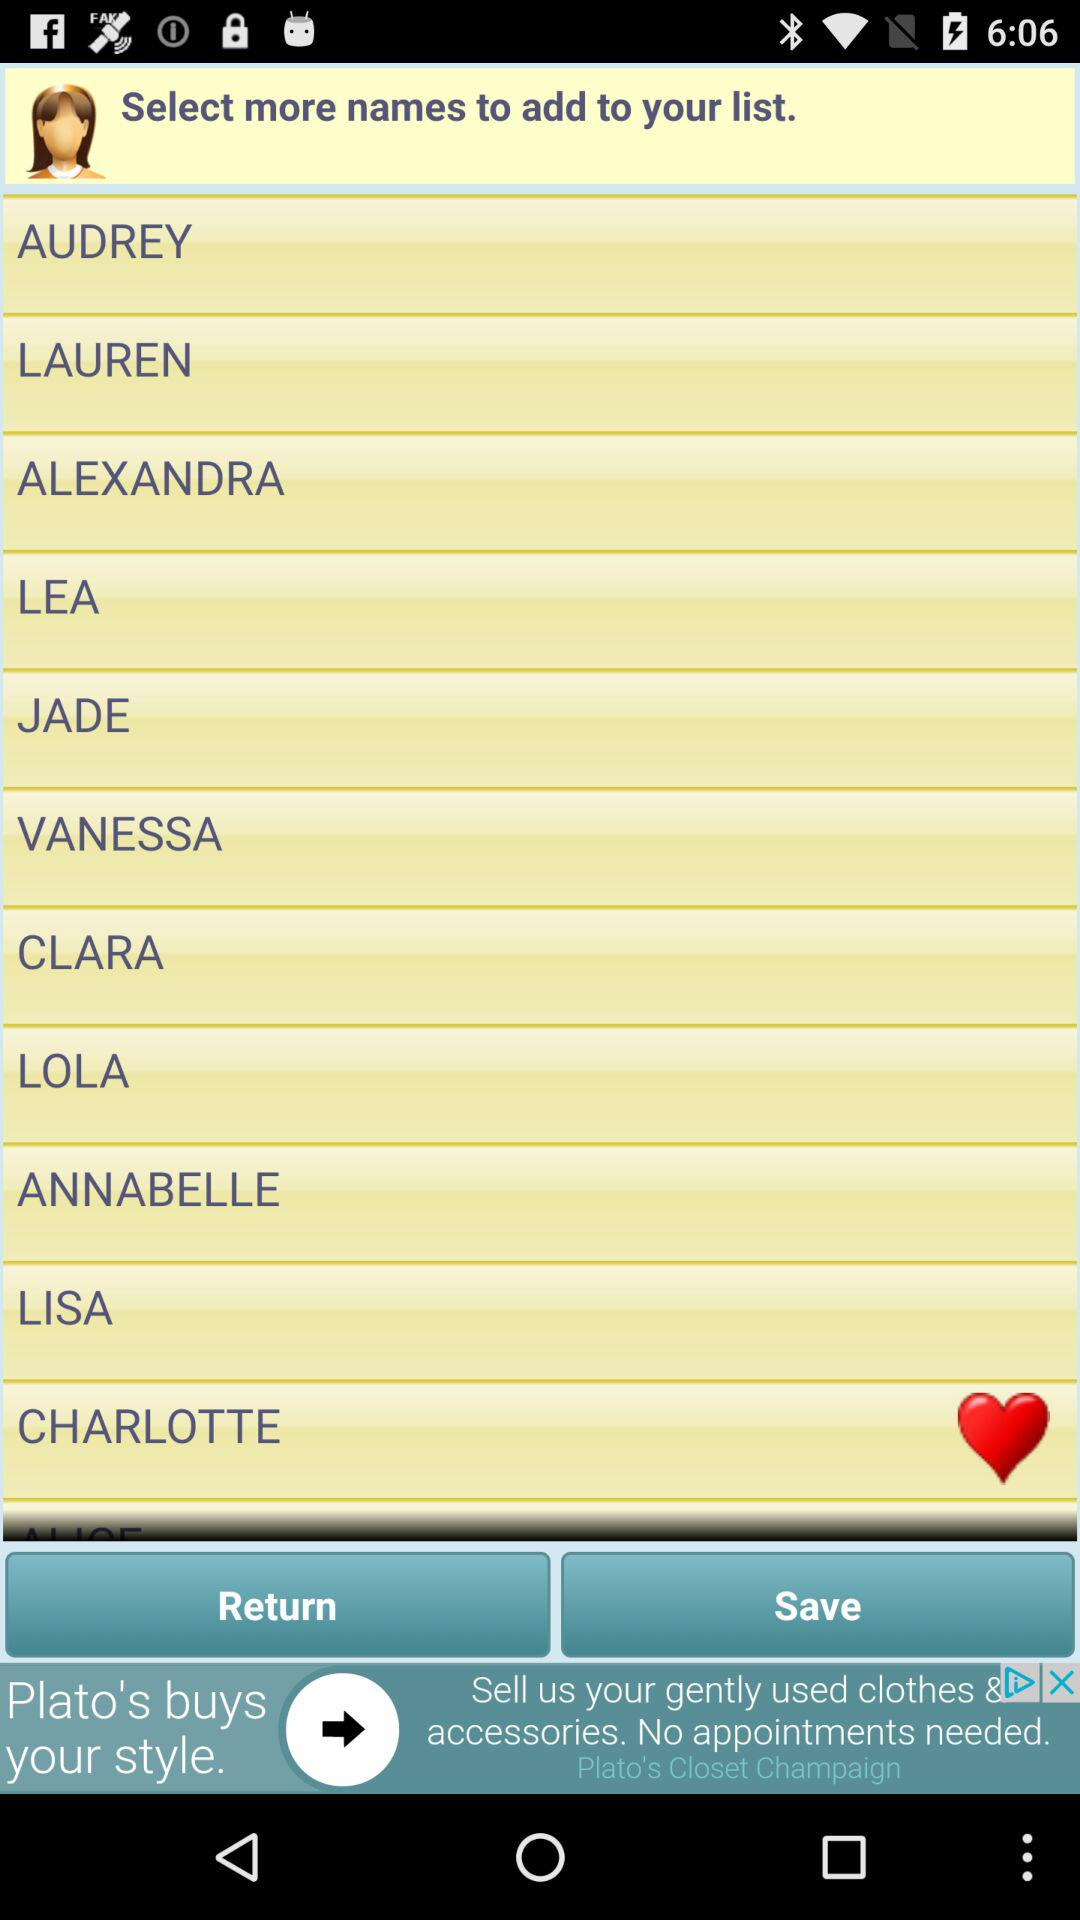Is there any indication of the app's broader theme or market focus based on the names listed? The names listed are diverse and commonly seen across various demographics. This suggests that the app might be targeting a wide audience, possibly focusing on lifestyle, social networking, or cultural communities where naming plays a significant role, such as in child naming, pet naming, or character naming in games or stories. 